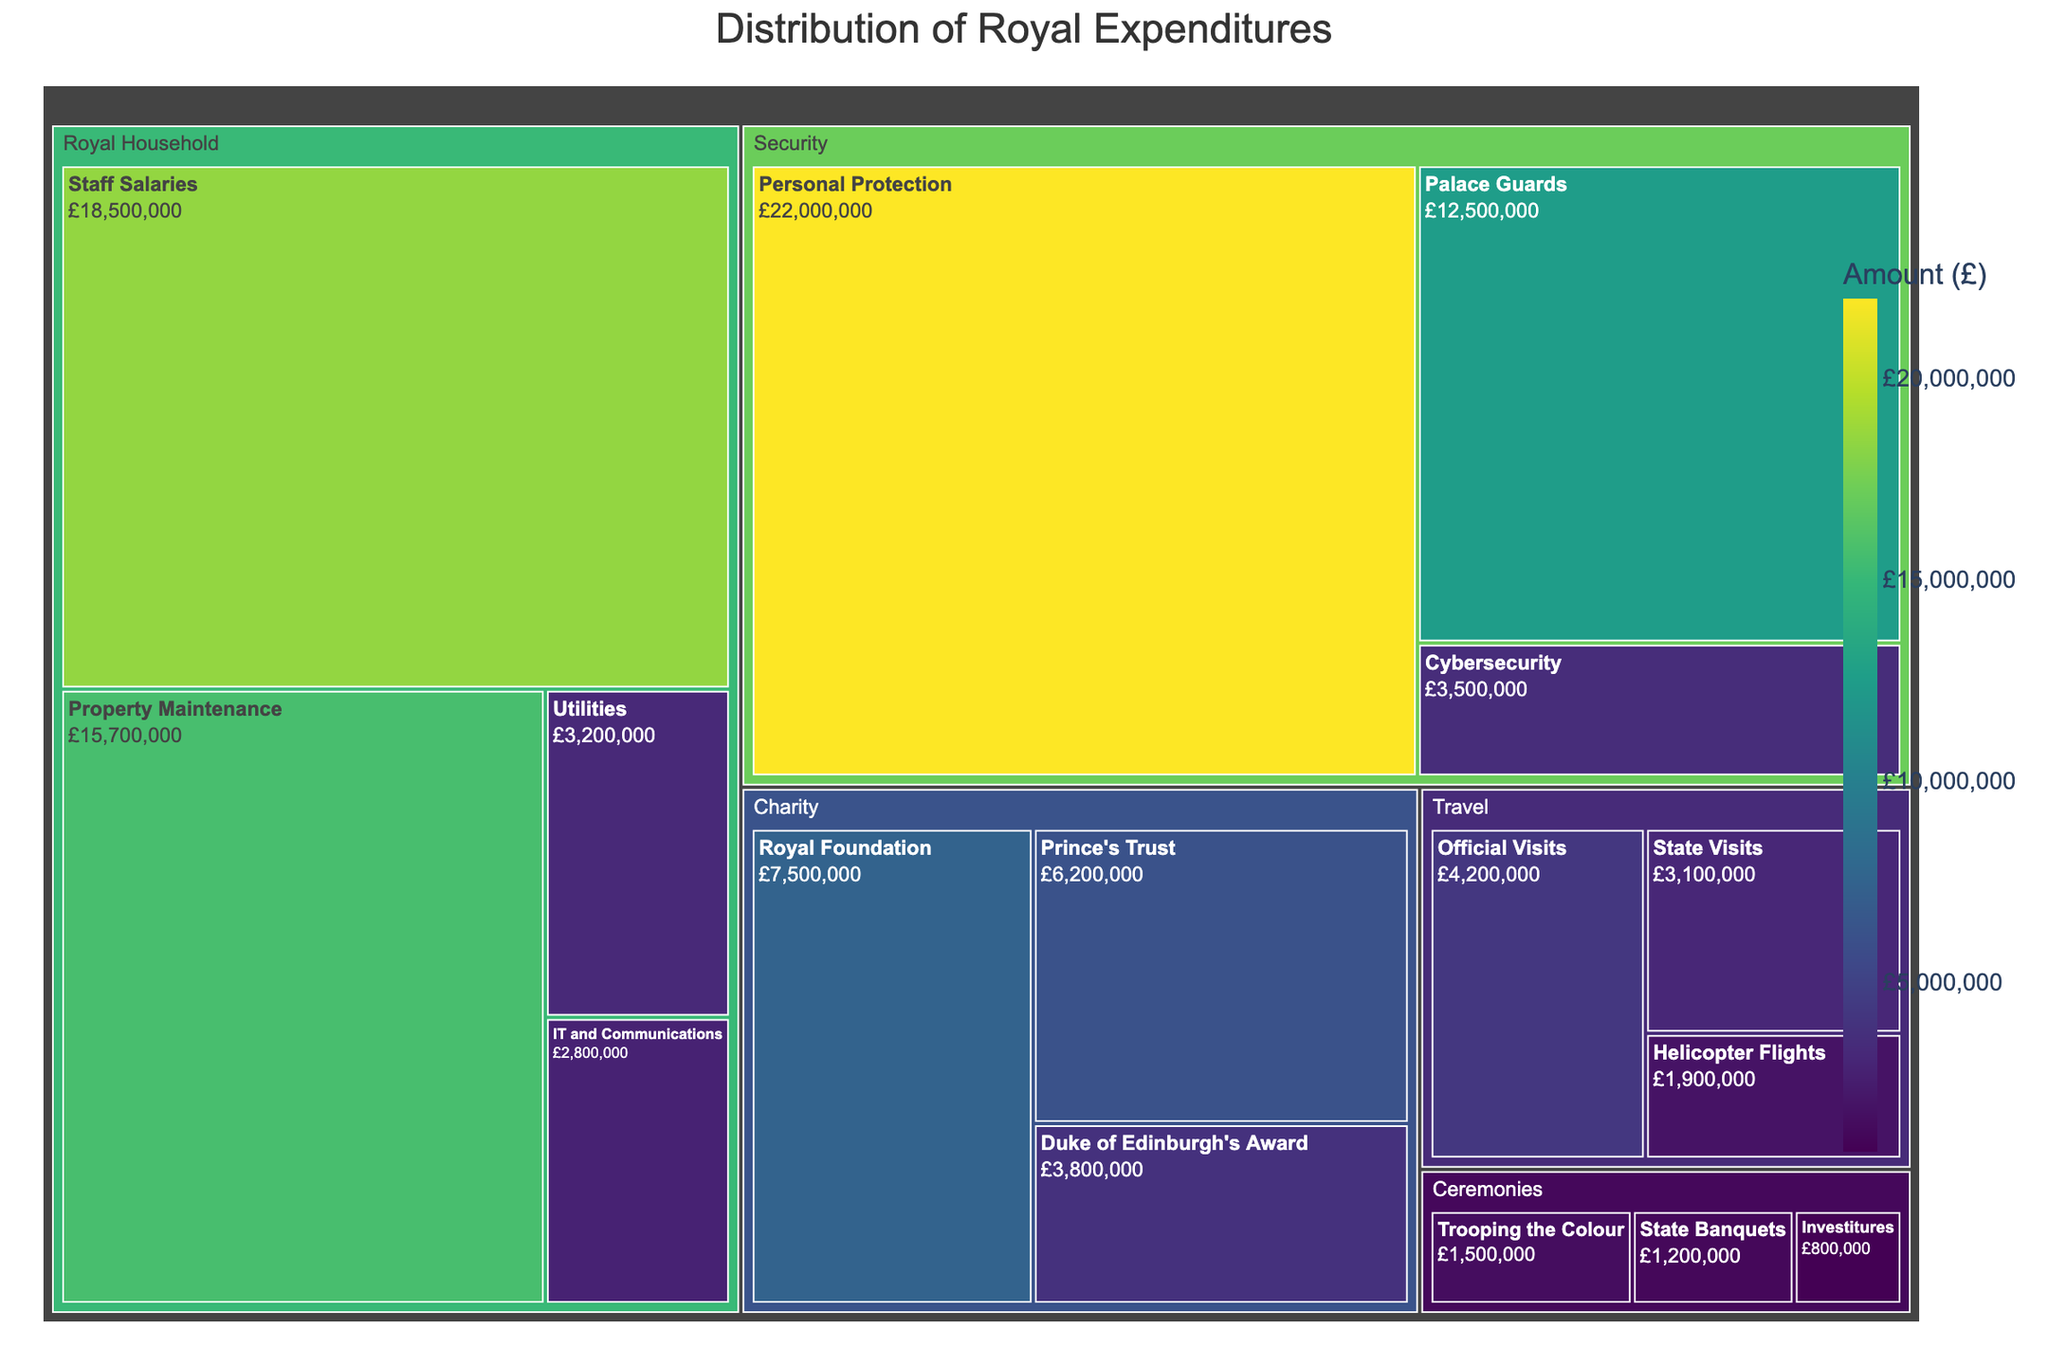What is the title of the treemap? The title is generally displayed at the top of the treemap and clearly indicates the subject of the plot.
Answer: Distribution of Royal Expenditures Which category has the highest expenditure? By looking at the largest block in the treemap, you can identify that category.
Answer: Security What is the total expenditure on 'Travel'? Adding up the values for all subcategories under 'Travel' gives the total expenditure. (4200000 + 3100000 + 1900000)
Answer: 9200000 How does 'Personal Protection' expenditure compare to 'Staff Salaries' expenditure? Compare the individual values of these subcategories to determine which is higher. (22000000 compared to 18500000)
Answer: Personal Protection is higher What's the proportion of 'Cybersecurity' expenditure in the 'Security' category? Divide the expenditure on 'Cybersecurity' by the total 'Security' expenditure. (3500000 / (22000000 + 12500000 + 3500000))
Answer: About 9.46% Which subcategory under 'Ceremonies' has the lowest expenditure? Look at the smallest block within the 'Ceremonies' category.
Answer: Investitures Is 'Property Maintenance' a larger expense than 'IT and Communications'? Compare the expenditure values directly. (15700000 vs. 2800000)
Answer: Yes What is the combined expenditure of the 'Charity' category? Sum the expenditures of all subcategories under 'Charity'. (7500000 + 6200000 + 3800000)
Answer: 17500000 How many categories are there in total? Count the primary divisions in the treemap.
Answer: 4 Which has a larger expenditure: 'Helicopter Flights' or 'Trooping the Colour'? Compare the values for these specific subcategories. (1900000 vs. 1500000)
Answer: Helicopter Flights How does the expenditure on 'Utilities' compare to 'Ceremonies'? Compare the expenditure of 'Utilities' to the total expenditure of all subcategories under 'Ceremonies'. (3200000 compared to (1500000 + 1200000 + 800000))
Answer: Utilities is higher 